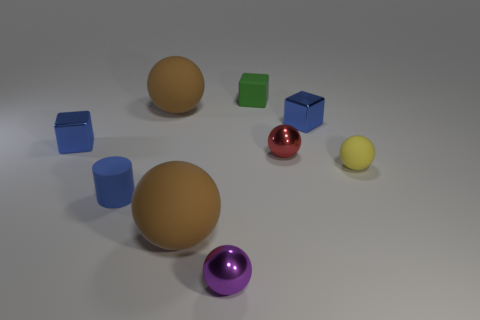There is a cube that is on the left side of the purple thing; is its color the same as the rubber cylinder that is in front of the tiny red sphere?
Make the answer very short. Yes. Is there another tiny ball that has the same material as the purple sphere?
Provide a succinct answer. Yes. Do the tiny yellow thing and the green thing have the same material?
Make the answer very short. Yes. There is a blue cube that is on the right side of the small red object; how many tiny cylinders are to the left of it?
Your answer should be very brief. 1. What number of green objects are either blocks or tiny metal spheres?
Offer a terse response. 1. What is the shape of the blue metal object that is on the left side of the large brown ball behind the matte ball that is to the right of the purple metallic object?
Offer a terse response. Cube. There is a matte ball that is the same size as the red metallic sphere; what color is it?
Give a very brief answer. Yellow. How many other tiny purple shiny things have the same shape as the purple thing?
Ensure brevity in your answer.  0. There is a red object; is its size the same as the blue thing on the right side of the matte cylinder?
Your answer should be very brief. Yes. The large rubber object that is right of the large brown object that is behind the blue cylinder is what shape?
Offer a terse response. Sphere. 